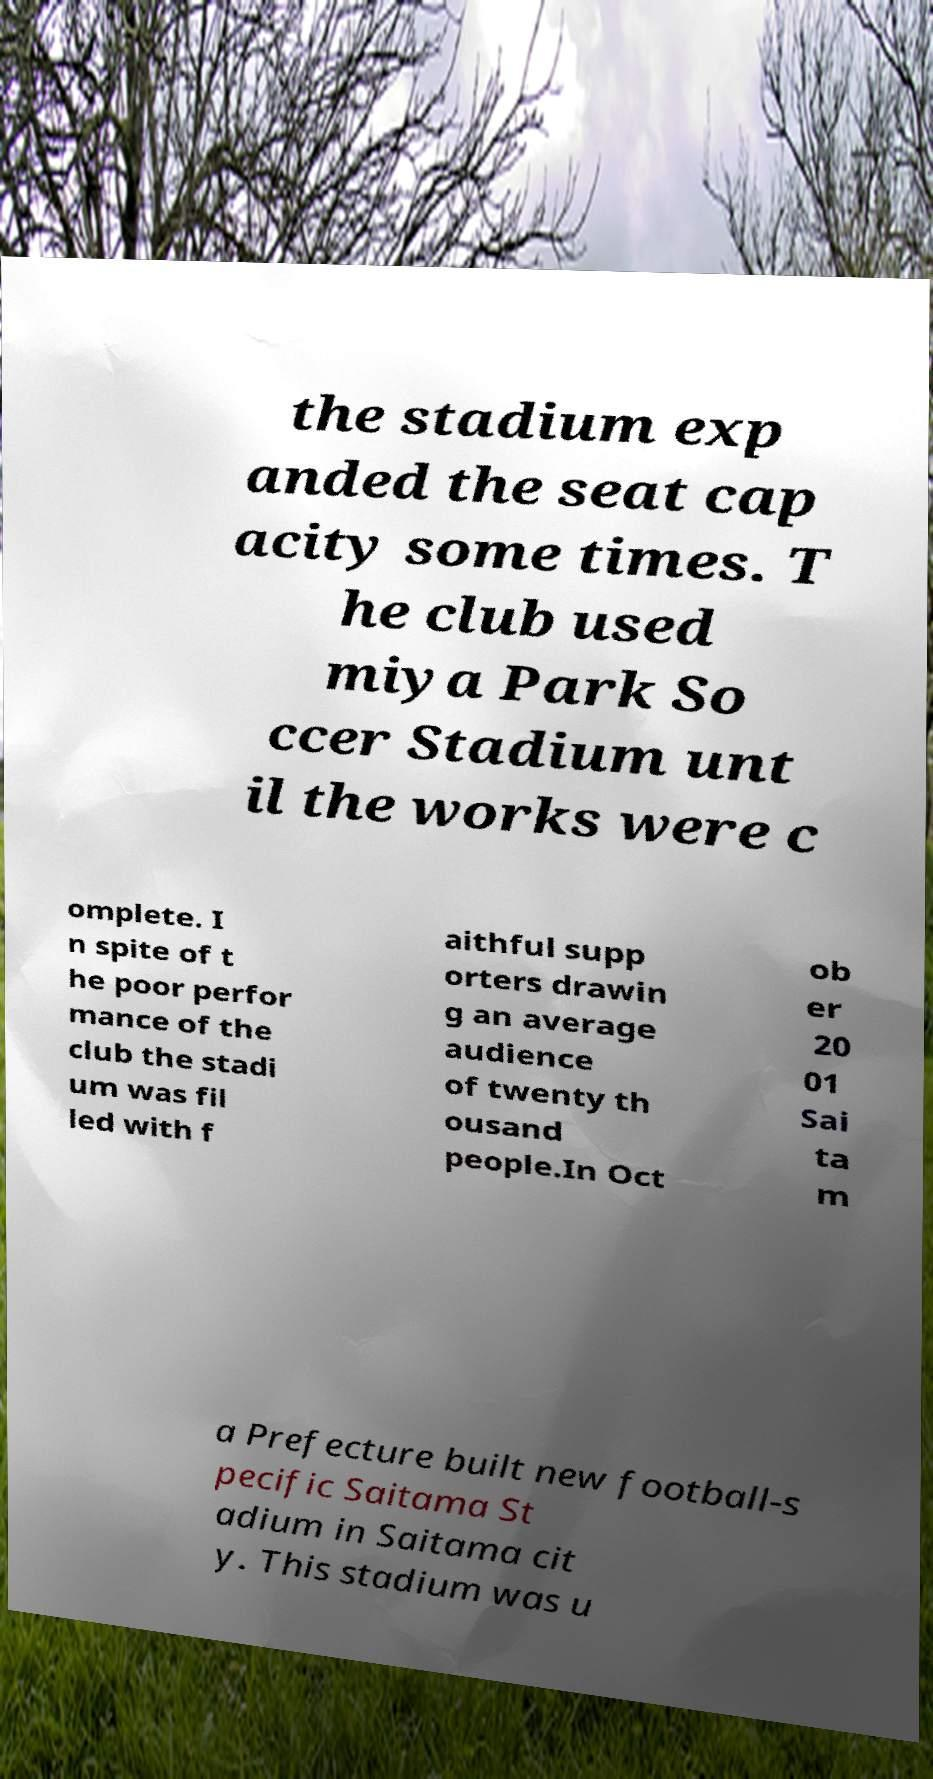What messages or text are displayed in this image? I need them in a readable, typed format. the stadium exp anded the seat cap acity some times. T he club used miya Park So ccer Stadium unt il the works were c omplete. I n spite of t he poor perfor mance of the club the stadi um was fil led with f aithful supp orters drawin g an average audience of twenty th ousand people.In Oct ob er 20 01 Sai ta m a Prefecture built new football-s pecific Saitama St adium in Saitama cit y. This stadium was u 